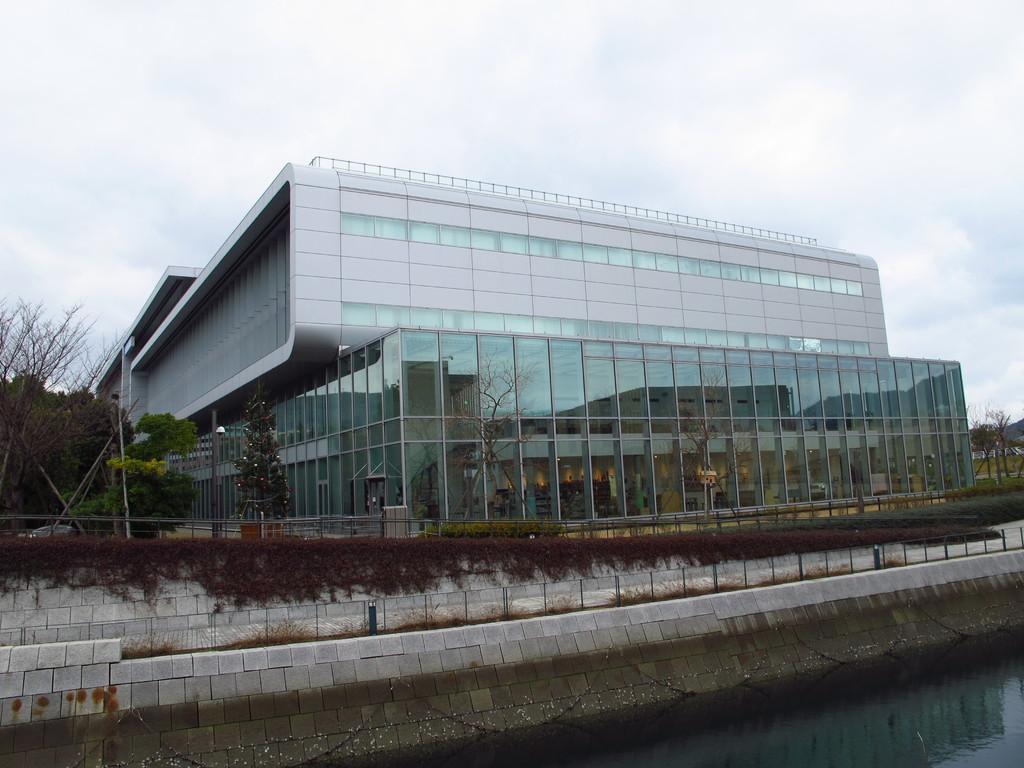In one or two sentences, can you explain what this image depicts? In this image we can see a building. We can also see a group of trees, plants, poles, a chain and a water body. On the backside we can see the sky which looks cloudy. 